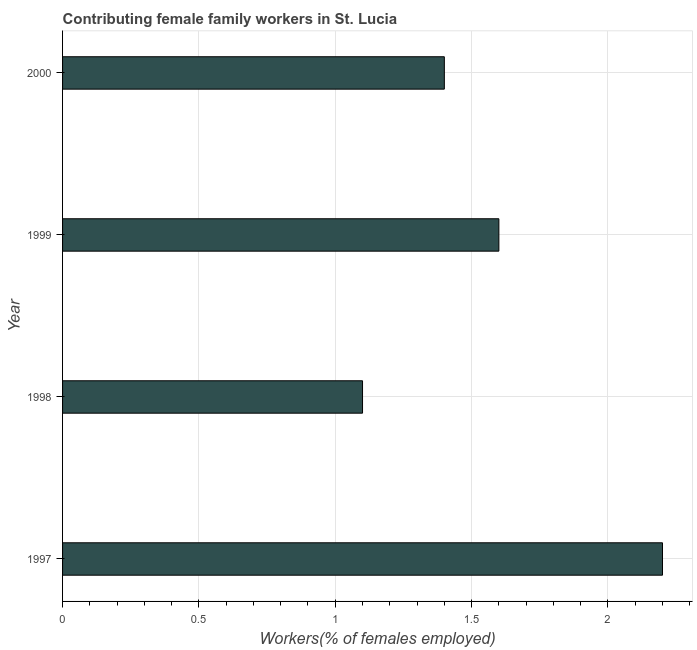Does the graph contain any zero values?
Provide a succinct answer. No. What is the title of the graph?
Your answer should be very brief. Contributing female family workers in St. Lucia. What is the label or title of the X-axis?
Make the answer very short. Workers(% of females employed). What is the contributing female family workers in 1997?
Your answer should be very brief. 2.2. Across all years, what is the maximum contributing female family workers?
Ensure brevity in your answer.  2.2. Across all years, what is the minimum contributing female family workers?
Your response must be concise. 1.1. In which year was the contributing female family workers minimum?
Provide a short and direct response. 1998. What is the sum of the contributing female family workers?
Offer a very short reply. 6.3. What is the average contributing female family workers per year?
Offer a very short reply. 1.57. What is the median contributing female family workers?
Your answer should be very brief. 1.5. In how many years, is the contributing female family workers greater than 1.5 %?
Keep it short and to the point. 2. Do a majority of the years between 1998 and 2000 (inclusive) have contributing female family workers greater than 1.2 %?
Offer a very short reply. Yes. What is the ratio of the contributing female family workers in 1998 to that in 1999?
Ensure brevity in your answer.  0.69. Is the contributing female family workers in 1997 less than that in 1998?
Your response must be concise. No. Is the difference between the contributing female family workers in 1997 and 1999 greater than the difference between any two years?
Your response must be concise. No. What is the difference between the highest and the second highest contributing female family workers?
Offer a terse response. 0.6. Is the sum of the contributing female family workers in 1997 and 1998 greater than the maximum contributing female family workers across all years?
Your answer should be compact. Yes. How many bars are there?
Keep it short and to the point. 4. Are all the bars in the graph horizontal?
Ensure brevity in your answer.  Yes. What is the difference between two consecutive major ticks on the X-axis?
Provide a short and direct response. 0.5. What is the Workers(% of females employed) in 1997?
Give a very brief answer. 2.2. What is the Workers(% of females employed) of 1998?
Give a very brief answer. 1.1. What is the Workers(% of females employed) of 1999?
Your response must be concise. 1.6. What is the Workers(% of females employed) in 2000?
Your answer should be very brief. 1.4. What is the difference between the Workers(% of females employed) in 1997 and 1998?
Keep it short and to the point. 1.1. What is the difference between the Workers(% of females employed) in 1997 and 2000?
Keep it short and to the point. 0.8. What is the difference between the Workers(% of females employed) in 1998 and 2000?
Your response must be concise. -0.3. What is the ratio of the Workers(% of females employed) in 1997 to that in 1999?
Your answer should be compact. 1.38. What is the ratio of the Workers(% of females employed) in 1997 to that in 2000?
Offer a very short reply. 1.57. What is the ratio of the Workers(% of females employed) in 1998 to that in 1999?
Offer a very short reply. 0.69. What is the ratio of the Workers(% of females employed) in 1998 to that in 2000?
Make the answer very short. 0.79. What is the ratio of the Workers(% of females employed) in 1999 to that in 2000?
Your answer should be compact. 1.14. 